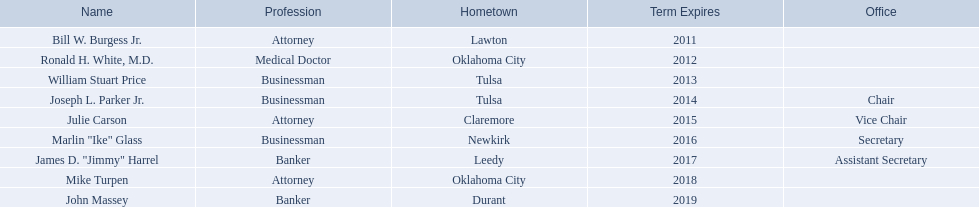Who are the entrepreneurs? Bill W. Burgess Jr., Ronald H. White, M.D., William Stuart Price, Joseph L. Parker Jr., Julie Carson, Marlin "Ike" Glass, James D. "Jimmy" Harrel, Mike Turpen, John Massey. Which were born in tulsa? William Stuart Price, Joseph L. Parker Jr. Of these, which one was not william stuart price? Joseph L. Parker Jr. Who are the oklahoma state regents for higher education? Bill W. Burgess Jr., Ronald H. White, M.D., William Stuart Price, Joseph L. Parker Jr., Julie Carson, Marlin "Ike" Glass, James D. "Jimmy" Harrel, Mike Turpen, John Massey. Where does ronald h. white hail from? Oklahoma City. Is there another regent with the same hometown as ronald h. white? Mike Turpen. 